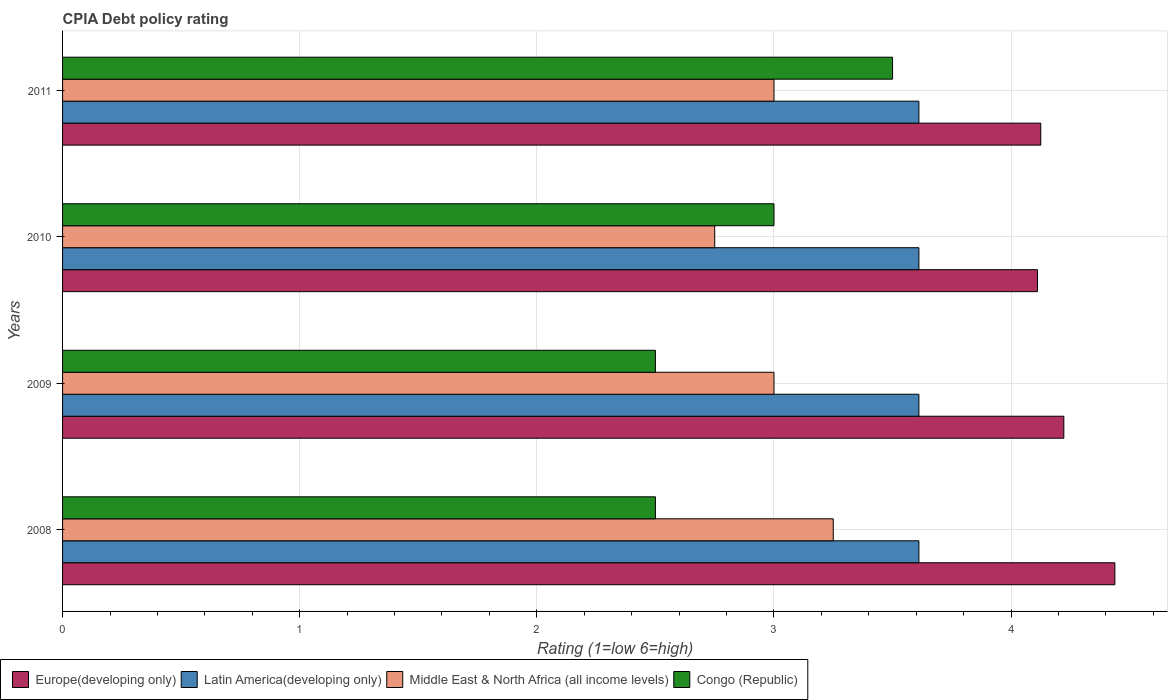How many groups of bars are there?
Give a very brief answer. 4. Are the number of bars per tick equal to the number of legend labels?
Your answer should be very brief. Yes. Are the number of bars on each tick of the Y-axis equal?
Provide a succinct answer. Yes. How many bars are there on the 4th tick from the bottom?
Offer a very short reply. 4. In how many cases, is the number of bars for a given year not equal to the number of legend labels?
Keep it short and to the point. 0. Across all years, what is the maximum CPIA rating in Europe(developing only)?
Your response must be concise. 4.44. Across all years, what is the minimum CPIA rating in Latin America(developing only)?
Make the answer very short. 3.61. What is the total CPIA rating in Latin America(developing only) in the graph?
Give a very brief answer. 14.44. What is the difference between the CPIA rating in Europe(developing only) in 2010 and that in 2011?
Keep it short and to the point. -0.01. What is the difference between the CPIA rating in Latin America(developing only) in 2009 and the CPIA rating in Middle East & North Africa (all income levels) in 2008?
Offer a terse response. 0.36. What is the average CPIA rating in Congo (Republic) per year?
Give a very brief answer. 2.88. In the year 2008, what is the difference between the CPIA rating in Latin America(developing only) and CPIA rating in Europe(developing only)?
Provide a short and direct response. -0.83. What is the ratio of the CPIA rating in Latin America(developing only) in 2008 to that in 2009?
Give a very brief answer. 1. Is the CPIA rating in Middle East & North Africa (all income levels) in 2009 less than that in 2010?
Give a very brief answer. No. Is it the case that in every year, the sum of the CPIA rating in Congo (Republic) and CPIA rating in Europe(developing only) is greater than the sum of CPIA rating in Middle East & North Africa (all income levels) and CPIA rating in Latin America(developing only)?
Keep it short and to the point. No. What does the 3rd bar from the top in 2008 represents?
Make the answer very short. Latin America(developing only). What does the 4th bar from the bottom in 2011 represents?
Ensure brevity in your answer.  Congo (Republic). Is it the case that in every year, the sum of the CPIA rating in Europe(developing only) and CPIA rating in Congo (Republic) is greater than the CPIA rating in Middle East & North Africa (all income levels)?
Your response must be concise. Yes. How many bars are there?
Make the answer very short. 16. Does the graph contain any zero values?
Offer a very short reply. No. Does the graph contain grids?
Your response must be concise. Yes. Where does the legend appear in the graph?
Your answer should be compact. Bottom left. How are the legend labels stacked?
Offer a terse response. Horizontal. What is the title of the graph?
Your answer should be compact. CPIA Debt policy rating. What is the label or title of the X-axis?
Your answer should be very brief. Rating (1=low 6=high). What is the label or title of the Y-axis?
Offer a terse response. Years. What is the Rating (1=low 6=high) in Europe(developing only) in 2008?
Your answer should be very brief. 4.44. What is the Rating (1=low 6=high) of Latin America(developing only) in 2008?
Make the answer very short. 3.61. What is the Rating (1=low 6=high) of Middle East & North Africa (all income levels) in 2008?
Ensure brevity in your answer.  3.25. What is the Rating (1=low 6=high) in Europe(developing only) in 2009?
Provide a succinct answer. 4.22. What is the Rating (1=low 6=high) of Latin America(developing only) in 2009?
Your response must be concise. 3.61. What is the Rating (1=low 6=high) of Europe(developing only) in 2010?
Offer a terse response. 4.11. What is the Rating (1=low 6=high) in Latin America(developing only) in 2010?
Your answer should be very brief. 3.61. What is the Rating (1=low 6=high) in Middle East & North Africa (all income levels) in 2010?
Provide a short and direct response. 2.75. What is the Rating (1=low 6=high) of Congo (Republic) in 2010?
Your response must be concise. 3. What is the Rating (1=low 6=high) of Europe(developing only) in 2011?
Provide a short and direct response. 4.12. What is the Rating (1=low 6=high) in Latin America(developing only) in 2011?
Make the answer very short. 3.61. What is the Rating (1=low 6=high) of Middle East & North Africa (all income levels) in 2011?
Keep it short and to the point. 3. What is the Rating (1=low 6=high) in Congo (Republic) in 2011?
Provide a short and direct response. 3.5. Across all years, what is the maximum Rating (1=low 6=high) in Europe(developing only)?
Provide a succinct answer. 4.44. Across all years, what is the maximum Rating (1=low 6=high) in Latin America(developing only)?
Offer a very short reply. 3.61. Across all years, what is the minimum Rating (1=low 6=high) of Europe(developing only)?
Offer a terse response. 4.11. Across all years, what is the minimum Rating (1=low 6=high) of Latin America(developing only)?
Offer a terse response. 3.61. Across all years, what is the minimum Rating (1=low 6=high) of Middle East & North Africa (all income levels)?
Make the answer very short. 2.75. What is the total Rating (1=low 6=high) in Europe(developing only) in the graph?
Your answer should be very brief. 16.9. What is the total Rating (1=low 6=high) of Latin America(developing only) in the graph?
Provide a succinct answer. 14.44. What is the total Rating (1=low 6=high) of Middle East & North Africa (all income levels) in the graph?
Provide a short and direct response. 12. What is the total Rating (1=low 6=high) in Congo (Republic) in the graph?
Your response must be concise. 11.5. What is the difference between the Rating (1=low 6=high) in Europe(developing only) in 2008 and that in 2009?
Keep it short and to the point. 0.22. What is the difference between the Rating (1=low 6=high) of Latin America(developing only) in 2008 and that in 2009?
Your response must be concise. 0. What is the difference between the Rating (1=low 6=high) of Middle East & North Africa (all income levels) in 2008 and that in 2009?
Provide a succinct answer. 0.25. What is the difference between the Rating (1=low 6=high) of Europe(developing only) in 2008 and that in 2010?
Provide a short and direct response. 0.33. What is the difference between the Rating (1=low 6=high) of Latin America(developing only) in 2008 and that in 2010?
Provide a succinct answer. 0. What is the difference between the Rating (1=low 6=high) in Congo (Republic) in 2008 and that in 2010?
Offer a terse response. -0.5. What is the difference between the Rating (1=low 6=high) of Europe(developing only) in 2008 and that in 2011?
Your answer should be very brief. 0.31. What is the difference between the Rating (1=low 6=high) in Congo (Republic) in 2008 and that in 2011?
Your answer should be compact. -1. What is the difference between the Rating (1=low 6=high) in Europe(developing only) in 2009 and that in 2010?
Offer a terse response. 0.11. What is the difference between the Rating (1=low 6=high) of Middle East & North Africa (all income levels) in 2009 and that in 2010?
Provide a short and direct response. 0.25. What is the difference between the Rating (1=low 6=high) of Europe(developing only) in 2009 and that in 2011?
Your answer should be compact. 0.1. What is the difference between the Rating (1=low 6=high) in Congo (Republic) in 2009 and that in 2011?
Your response must be concise. -1. What is the difference between the Rating (1=low 6=high) of Europe(developing only) in 2010 and that in 2011?
Provide a short and direct response. -0.01. What is the difference between the Rating (1=low 6=high) in Latin America(developing only) in 2010 and that in 2011?
Offer a very short reply. 0. What is the difference between the Rating (1=low 6=high) in Europe(developing only) in 2008 and the Rating (1=low 6=high) in Latin America(developing only) in 2009?
Give a very brief answer. 0.83. What is the difference between the Rating (1=low 6=high) of Europe(developing only) in 2008 and the Rating (1=low 6=high) of Middle East & North Africa (all income levels) in 2009?
Your answer should be very brief. 1.44. What is the difference between the Rating (1=low 6=high) in Europe(developing only) in 2008 and the Rating (1=low 6=high) in Congo (Republic) in 2009?
Keep it short and to the point. 1.94. What is the difference between the Rating (1=low 6=high) in Latin America(developing only) in 2008 and the Rating (1=low 6=high) in Middle East & North Africa (all income levels) in 2009?
Your answer should be very brief. 0.61. What is the difference between the Rating (1=low 6=high) in Latin America(developing only) in 2008 and the Rating (1=low 6=high) in Congo (Republic) in 2009?
Give a very brief answer. 1.11. What is the difference between the Rating (1=low 6=high) of Middle East & North Africa (all income levels) in 2008 and the Rating (1=low 6=high) of Congo (Republic) in 2009?
Offer a very short reply. 0.75. What is the difference between the Rating (1=low 6=high) in Europe(developing only) in 2008 and the Rating (1=low 6=high) in Latin America(developing only) in 2010?
Ensure brevity in your answer.  0.83. What is the difference between the Rating (1=low 6=high) of Europe(developing only) in 2008 and the Rating (1=low 6=high) of Middle East & North Africa (all income levels) in 2010?
Offer a terse response. 1.69. What is the difference between the Rating (1=low 6=high) in Europe(developing only) in 2008 and the Rating (1=low 6=high) in Congo (Republic) in 2010?
Give a very brief answer. 1.44. What is the difference between the Rating (1=low 6=high) in Latin America(developing only) in 2008 and the Rating (1=low 6=high) in Middle East & North Africa (all income levels) in 2010?
Give a very brief answer. 0.86. What is the difference between the Rating (1=low 6=high) of Latin America(developing only) in 2008 and the Rating (1=low 6=high) of Congo (Republic) in 2010?
Ensure brevity in your answer.  0.61. What is the difference between the Rating (1=low 6=high) of Middle East & North Africa (all income levels) in 2008 and the Rating (1=low 6=high) of Congo (Republic) in 2010?
Keep it short and to the point. 0.25. What is the difference between the Rating (1=low 6=high) of Europe(developing only) in 2008 and the Rating (1=low 6=high) of Latin America(developing only) in 2011?
Offer a very short reply. 0.83. What is the difference between the Rating (1=low 6=high) of Europe(developing only) in 2008 and the Rating (1=low 6=high) of Middle East & North Africa (all income levels) in 2011?
Ensure brevity in your answer.  1.44. What is the difference between the Rating (1=low 6=high) in Europe(developing only) in 2008 and the Rating (1=low 6=high) in Congo (Republic) in 2011?
Provide a short and direct response. 0.94. What is the difference between the Rating (1=low 6=high) in Latin America(developing only) in 2008 and the Rating (1=low 6=high) in Middle East & North Africa (all income levels) in 2011?
Ensure brevity in your answer.  0.61. What is the difference between the Rating (1=low 6=high) in Latin America(developing only) in 2008 and the Rating (1=low 6=high) in Congo (Republic) in 2011?
Provide a succinct answer. 0.11. What is the difference between the Rating (1=low 6=high) of Middle East & North Africa (all income levels) in 2008 and the Rating (1=low 6=high) of Congo (Republic) in 2011?
Your response must be concise. -0.25. What is the difference between the Rating (1=low 6=high) of Europe(developing only) in 2009 and the Rating (1=low 6=high) of Latin America(developing only) in 2010?
Provide a short and direct response. 0.61. What is the difference between the Rating (1=low 6=high) in Europe(developing only) in 2009 and the Rating (1=low 6=high) in Middle East & North Africa (all income levels) in 2010?
Keep it short and to the point. 1.47. What is the difference between the Rating (1=low 6=high) of Europe(developing only) in 2009 and the Rating (1=low 6=high) of Congo (Republic) in 2010?
Make the answer very short. 1.22. What is the difference between the Rating (1=low 6=high) of Latin America(developing only) in 2009 and the Rating (1=low 6=high) of Middle East & North Africa (all income levels) in 2010?
Offer a very short reply. 0.86. What is the difference between the Rating (1=low 6=high) in Latin America(developing only) in 2009 and the Rating (1=low 6=high) in Congo (Republic) in 2010?
Keep it short and to the point. 0.61. What is the difference between the Rating (1=low 6=high) of Europe(developing only) in 2009 and the Rating (1=low 6=high) of Latin America(developing only) in 2011?
Offer a terse response. 0.61. What is the difference between the Rating (1=low 6=high) of Europe(developing only) in 2009 and the Rating (1=low 6=high) of Middle East & North Africa (all income levels) in 2011?
Your response must be concise. 1.22. What is the difference between the Rating (1=low 6=high) in Europe(developing only) in 2009 and the Rating (1=low 6=high) in Congo (Republic) in 2011?
Offer a very short reply. 0.72. What is the difference between the Rating (1=low 6=high) of Latin America(developing only) in 2009 and the Rating (1=low 6=high) of Middle East & North Africa (all income levels) in 2011?
Give a very brief answer. 0.61. What is the difference between the Rating (1=low 6=high) of Middle East & North Africa (all income levels) in 2009 and the Rating (1=low 6=high) of Congo (Republic) in 2011?
Provide a short and direct response. -0.5. What is the difference between the Rating (1=low 6=high) in Europe(developing only) in 2010 and the Rating (1=low 6=high) in Latin America(developing only) in 2011?
Your answer should be compact. 0.5. What is the difference between the Rating (1=low 6=high) in Europe(developing only) in 2010 and the Rating (1=low 6=high) in Congo (Republic) in 2011?
Keep it short and to the point. 0.61. What is the difference between the Rating (1=low 6=high) in Latin America(developing only) in 2010 and the Rating (1=low 6=high) in Middle East & North Africa (all income levels) in 2011?
Provide a succinct answer. 0.61. What is the difference between the Rating (1=low 6=high) in Middle East & North Africa (all income levels) in 2010 and the Rating (1=low 6=high) in Congo (Republic) in 2011?
Give a very brief answer. -0.75. What is the average Rating (1=low 6=high) of Europe(developing only) per year?
Provide a succinct answer. 4.22. What is the average Rating (1=low 6=high) of Latin America(developing only) per year?
Offer a terse response. 3.61. What is the average Rating (1=low 6=high) of Congo (Republic) per year?
Give a very brief answer. 2.88. In the year 2008, what is the difference between the Rating (1=low 6=high) of Europe(developing only) and Rating (1=low 6=high) of Latin America(developing only)?
Offer a very short reply. 0.83. In the year 2008, what is the difference between the Rating (1=low 6=high) of Europe(developing only) and Rating (1=low 6=high) of Middle East & North Africa (all income levels)?
Provide a short and direct response. 1.19. In the year 2008, what is the difference between the Rating (1=low 6=high) of Europe(developing only) and Rating (1=low 6=high) of Congo (Republic)?
Offer a very short reply. 1.94. In the year 2008, what is the difference between the Rating (1=low 6=high) in Latin America(developing only) and Rating (1=low 6=high) in Middle East & North Africa (all income levels)?
Provide a succinct answer. 0.36. In the year 2008, what is the difference between the Rating (1=low 6=high) in Latin America(developing only) and Rating (1=low 6=high) in Congo (Republic)?
Provide a succinct answer. 1.11. In the year 2009, what is the difference between the Rating (1=low 6=high) in Europe(developing only) and Rating (1=low 6=high) in Latin America(developing only)?
Your answer should be very brief. 0.61. In the year 2009, what is the difference between the Rating (1=low 6=high) of Europe(developing only) and Rating (1=low 6=high) of Middle East & North Africa (all income levels)?
Provide a succinct answer. 1.22. In the year 2009, what is the difference between the Rating (1=low 6=high) of Europe(developing only) and Rating (1=low 6=high) of Congo (Republic)?
Your answer should be very brief. 1.72. In the year 2009, what is the difference between the Rating (1=low 6=high) in Latin America(developing only) and Rating (1=low 6=high) in Middle East & North Africa (all income levels)?
Provide a short and direct response. 0.61. In the year 2009, what is the difference between the Rating (1=low 6=high) of Middle East & North Africa (all income levels) and Rating (1=low 6=high) of Congo (Republic)?
Your answer should be compact. 0.5. In the year 2010, what is the difference between the Rating (1=low 6=high) of Europe(developing only) and Rating (1=low 6=high) of Latin America(developing only)?
Provide a succinct answer. 0.5. In the year 2010, what is the difference between the Rating (1=low 6=high) in Europe(developing only) and Rating (1=low 6=high) in Middle East & North Africa (all income levels)?
Your answer should be compact. 1.36. In the year 2010, what is the difference between the Rating (1=low 6=high) in Latin America(developing only) and Rating (1=low 6=high) in Middle East & North Africa (all income levels)?
Offer a very short reply. 0.86. In the year 2010, what is the difference between the Rating (1=low 6=high) of Latin America(developing only) and Rating (1=low 6=high) of Congo (Republic)?
Give a very brief answer. 0.61. In the year 2011, what is the difference between the Rating (1=low 6=high) of Europe(developing only) and Rating (1=low 6=high) of Latin America(developing only)?
Make the answer very short. 0.51. In the year 2011, what is the difference between the Rating (1=low 6=high) in Europe(developing only) and Rating (1=low 6=high) in Middle East & North Africa (all income levels)?
Provide a short and direct response. 1.12. In the year 2011, what is the difference between the Rating (1=low 6=high) in Latin America(developing only) and Rating (1=low 6=high) in Middle East & North Africa (all income levels)?
Offer a terse response. 0.61. In the year 2011, what is the difference between the Rating (1=low 6=high) in Latin America(developing only) and Rating (1=low 6=high) in Congo (Republic)?
Ensure brevity in your answer.  0.11. In the year 2011, what is the difference between the Rating (1=low 6=high) of Middle East & North Africa (all income levels) and Rating (1=low 6=high) of Congo (Republic)?
Give a very brief answer. -0.5. What is the ratio of the Rating (1=low 6=high) in Europe(developing only) in 2008 to that in 2009?
Make the answer very short. 1.05. What is the ratio of the Rating (1=low 6=high) of Latin America(developing only) in 2008 to that in 2009?
Provide a short and direct response. 1. What is the ratio of the Rating (1=low 6=high) of Middle East & North Africa (all income levels) in 2008 to that in 2009?
Keep it short and to the point. 1.08. What is the ratio of the Rating (1=low 6=high) of Europe(developing only) in 2008 to that in 2010?
Your answer should be very brief. 1.08. What is the ratio of the Rating (1=low 6=high) in Middle East & North Africa (all income levels) in 2008 to that in 2010?
Ensure brevity in your answer.  1.18. What is the ratio of the Rating (1=low 6=high) of Europe(developing only) in 2008 to that in 2011?
Make the answer very short. 1.08. What is the ratio of the Rating (1=low 6=high) of Latin America(developing only) in 2008 to that in 2011?
Keep it short and to the point. 1. What is the ratio of the Rating (1=low 6=high) of Middle East & North Africa (all income levels) in 2009 to that in 2010?
Provide a short and direct response. 1.09. What is the ratio of the Rating (1=low 6=high) of Europe(developing only) in 2009 to that in 2011?
Your answer should be compact. 1.02. What is the ratio of the Rating (1=low 6=high) of Middle East & North Africa (all income levels) in 2009 to that in 2011?
Ensure brevity in your answer.  1. What is the ratio of the Rating (1=low 6=high) of Middle East & North Africa (all income levels) in 2010 to that in 2011?
Ensure brevity in your answer.  0.92. What is the ratio of the Rating (1=low 6=high) of Congo (Republic) in 2010 to that in 2011?
Your response must be concise. 0.86. What is the difference between the highest and the second highest Rating (1=low 6=high) of Europe(developing only)?
Ensure brevity in your answer.  0.22. What is the difference between the highest and the second highest Rating (1=low 6=high) of Middle East & North Africa (all income levels)?
Your answer should be compact. 0.25. What is the difference between the highest and the second highest Rating (1=low 6=high) of Congo (Republic)?
Provide a short and direct response. 0.5. What is the difference between the highest and the lowest Rating (1=low 6=high) of Europe(developing only)?
Ensure brevity in your answer.  0.33. What is the difference between the highest and the lowest Rating (1=low 6=high) of Latin America(developing only)?
Offer a very short reply. 0. 